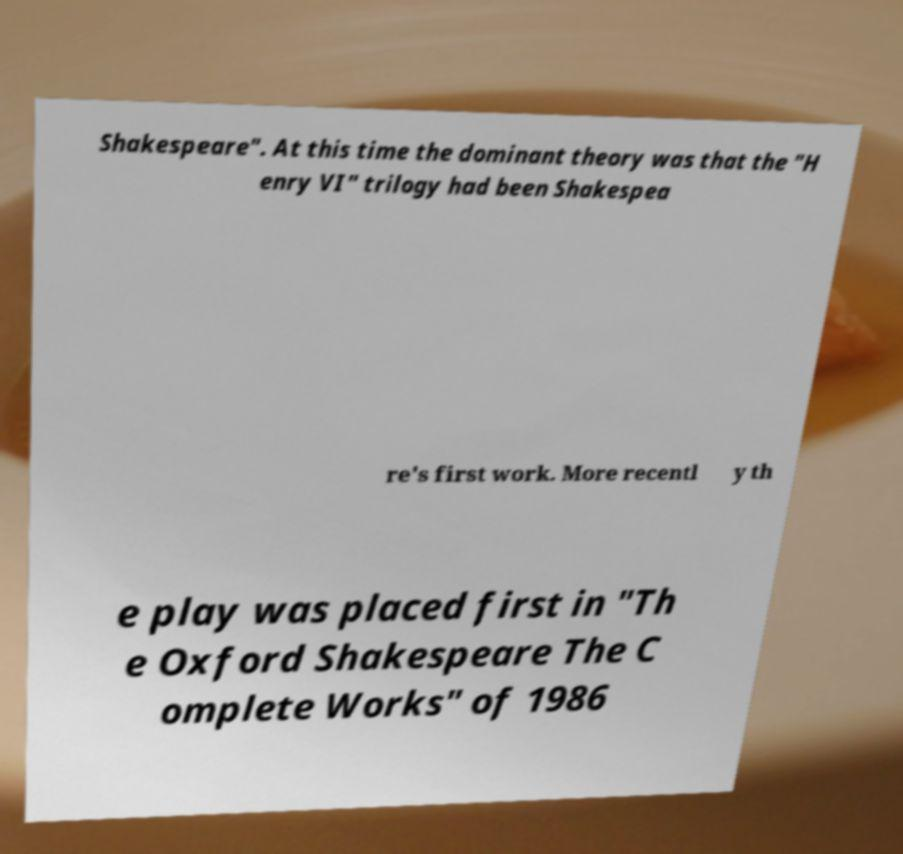I need the written content from this picture converted into text. Can you do that? Shakespeare". At this time the dominant theory was that the "H enry VI" trilogy had been Shakespea re's first work. More recentl y th e play was placed first in "Th e Oxford Shakespeare The C omplete Works" of 1986 